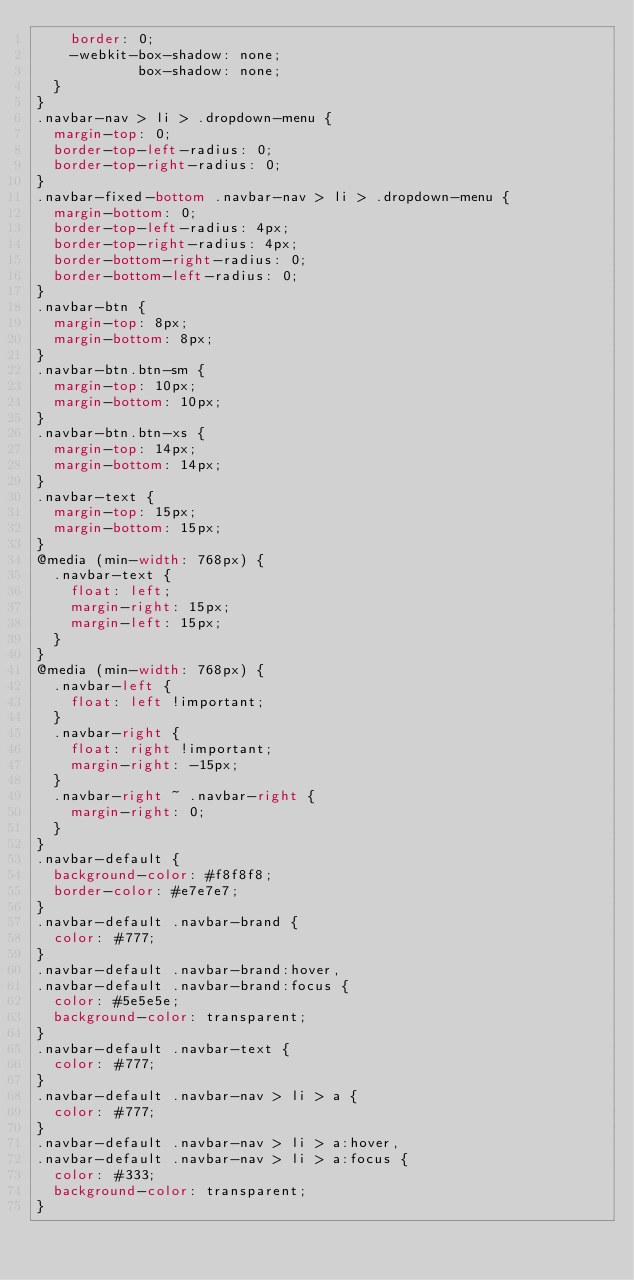Convert code to text. <code><loc_0><loc_0><loc_500><loc_500><_CSS_>    border: 0;
    -webkit-box-shadow: none;
            box-shadow: none;
  }
}
.navbar-nav > li > .dropdown-menu {
  margin-top: 0;
  border-top-left-radius: 0;
  border-top-right-radius: 0;
}
.navbar-fixed-bottom .navbar-nav > li > .dropdown-menu {
  margin-bottom: 0;
  border-top-left-radius: 4px;
  border-top-right-radius: 4px;
  border-bottom-right-radius: 0;
  border-bottom-left-radius: 0;
}
.navbar-btn {
  margin-top: 8px;
  margin-bottom: 8px;
}
.navbar-btn.btn-sm {
  margin-top: 10px;
  margin-bottom: 10px;
}
.navbar-btn.btn-xs {
  margin-top: 14px;
  margin-bottom: 14px;
}
.navbar-text {
  margin-top: 15px;
  margin-bottom: 15px;
}
@media (min-width: 768px) {
  .navbar-text {
    float: left;
    margin-right: 15px;
    margin-left: 15px;
  }
}
@media (min-width: 768px) {
  .navbar-left {
    float: left !important;
  }
  .navbar-right {
    float: right !important;
    margin-right: -15px;
  }
  .navbar-right ~ .navbar-right {
    margin-right: 0;
  }
}
.navbar-default {
  background-color: #f8f8f8;
  border-color: #e7e7e7;
}
.navbar-default .navbar-brand {
  color: #777;
}
.navbar-default .navbar-brand:hover,
.navbar-default .navbar-brand:focus {
  color: #5e5e5e;
  background-color: transparent;
}
.navbar-default .navbar-text {
  color: #777;
}
.navbar-default .navbar-nav > li > a {
  color: #777;
}
.navbar-default .navbar-nav > li > a:hover,
.navbar-default .navbar-nav > li > a:focus {
  color: #333;
  background-color: transparent;
}</code> 